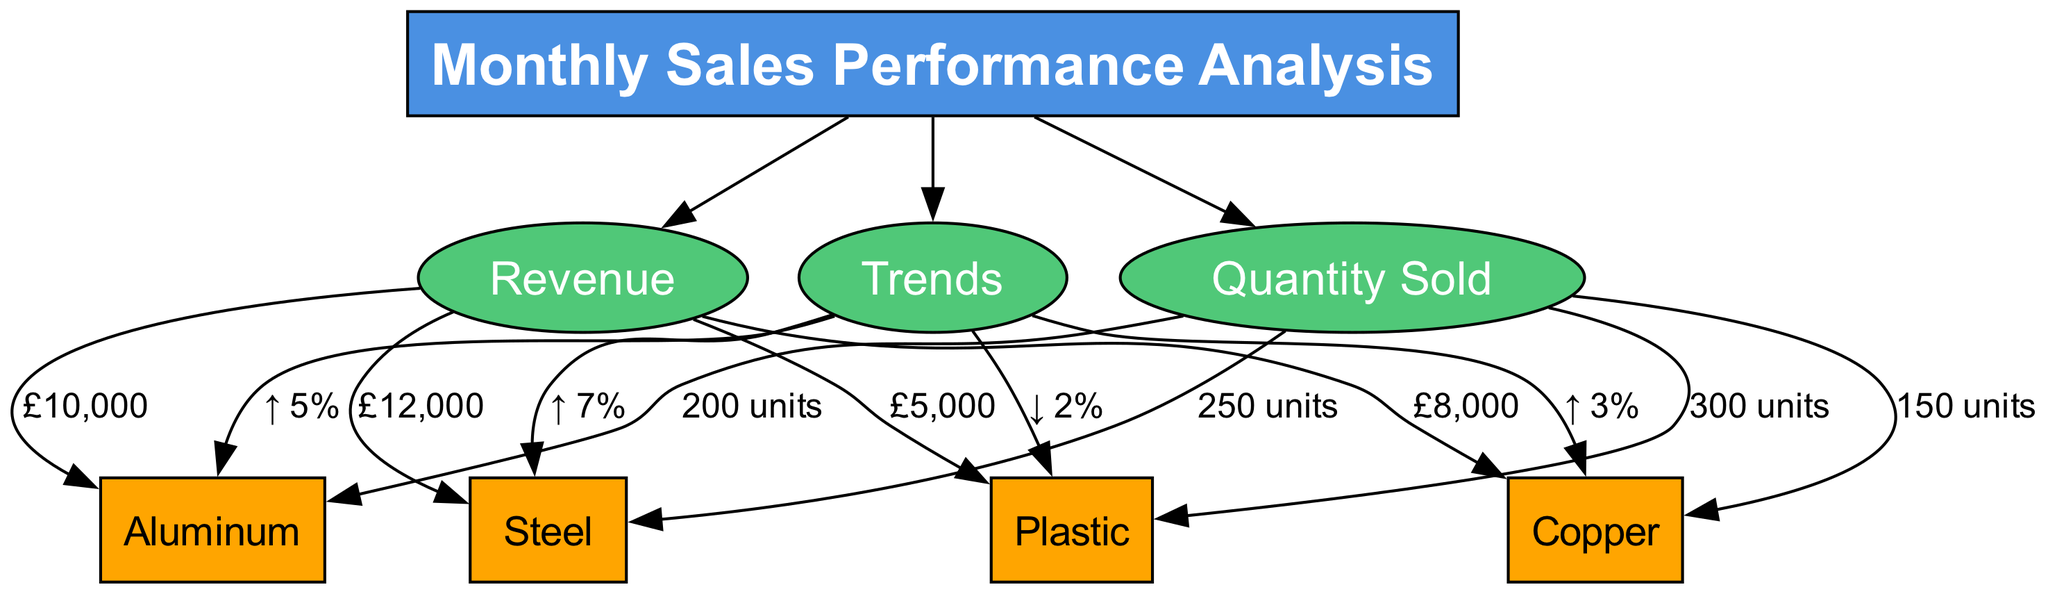What is the revenue for Aluminum? The diagram shows that the revenue for Aluminum is linked from the "Revenue" category to the Aluminum node, where the label states "£10,000."
Answer: £10,000 How many units of Copper were sold? The diagram indicates that from the "Quantity Sold" category to the Copper node, it states "150 units," showing the sales performance for Copper.
Answer: 150 units What is the trend for Plastic? The trend information flows from the "Trends" category to the Plastic node, which indicates a decrease represented by "↓ 2%."
Answer: ↓ 2% Which material has the highest revenue? By comparing the revenue amounts listed for each material under the "Revenue" category, Steel has the highest value with "£12,000."
Answer: Steel What is the total number of nodes in the diagram? The diagram lists a total of 8 nodes, counting the main header and various categories and materials (6 materials + 3 categories).
Answer: 8 Which material experienced the largest percentage increase in sales trend? From the "Trends" category, the Aluminum node shows an increase of "↑ 5%", which is the highest percentage increase compared to the other materials.
Answer: Aluminum What is the total revenue from all materials combined? By adding the individual revenues (Aluminum £10,000 + Copper £8,000 + Plastic £5,000 + Steel £12,000), the total revenue can be calculated. The result is £35,000.
Answer: £35,000 What percentage increase did Steel experience? The Steel node under "Trends" shows "↑ 7%", indicating that Steel had a 7% increase in sales trend.
Answer: ↑ 7% Which material has the lowest quantity sold? The data shows that Copper has the lowest quantity sold with "150 units" when compared across all materials.
Answer: Copper 